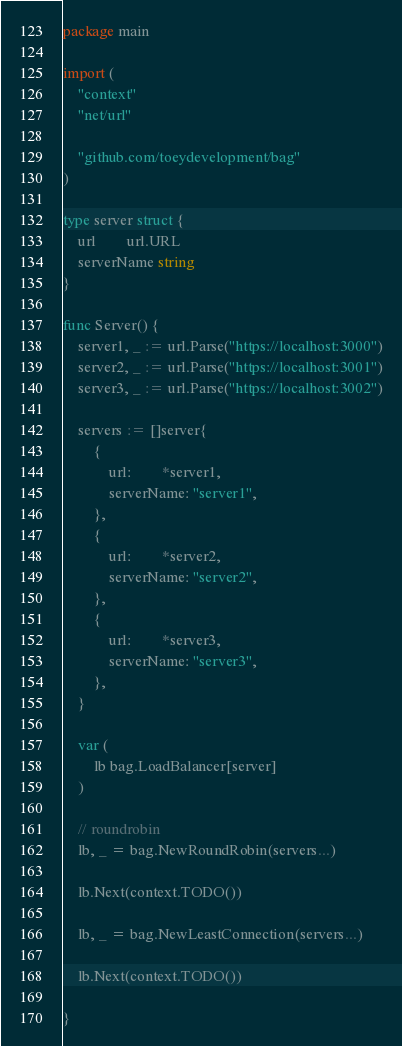<code> <loc_0><loc_0><loc_500><loc_500><_Go_>package main

import (
	"context"
	"net/url"

	"github.com/toeydevelopment/bag"
)

type server struct {
	url        url.URL
	serverName string
}

func Server() {
	server1, _ := url.Parse("https://localhost:3000")
	server2, _ := url.Parse("https://localhost:3001")
	server3, _ := url.Parse("https://localhost:3002")

	servers := []server{
		{
			url:        *server1,
			serverName: "server1",
		},
		{
			url:        *server2,
			serverName: "server2",
		},
		{
			url:        *server3,
			serverName: "server3",
		},
	}

	var (
		lb bag.LoadBalancer[server]
	)

	// roundrobin
	lb, _ = bag.NewRoundRobin(servers...)

	lb.Next(context.TODO())

	lb, _ = bag.NewLeastConnection(servers...)

	lb.Next(context.TODO())

}
</code> 